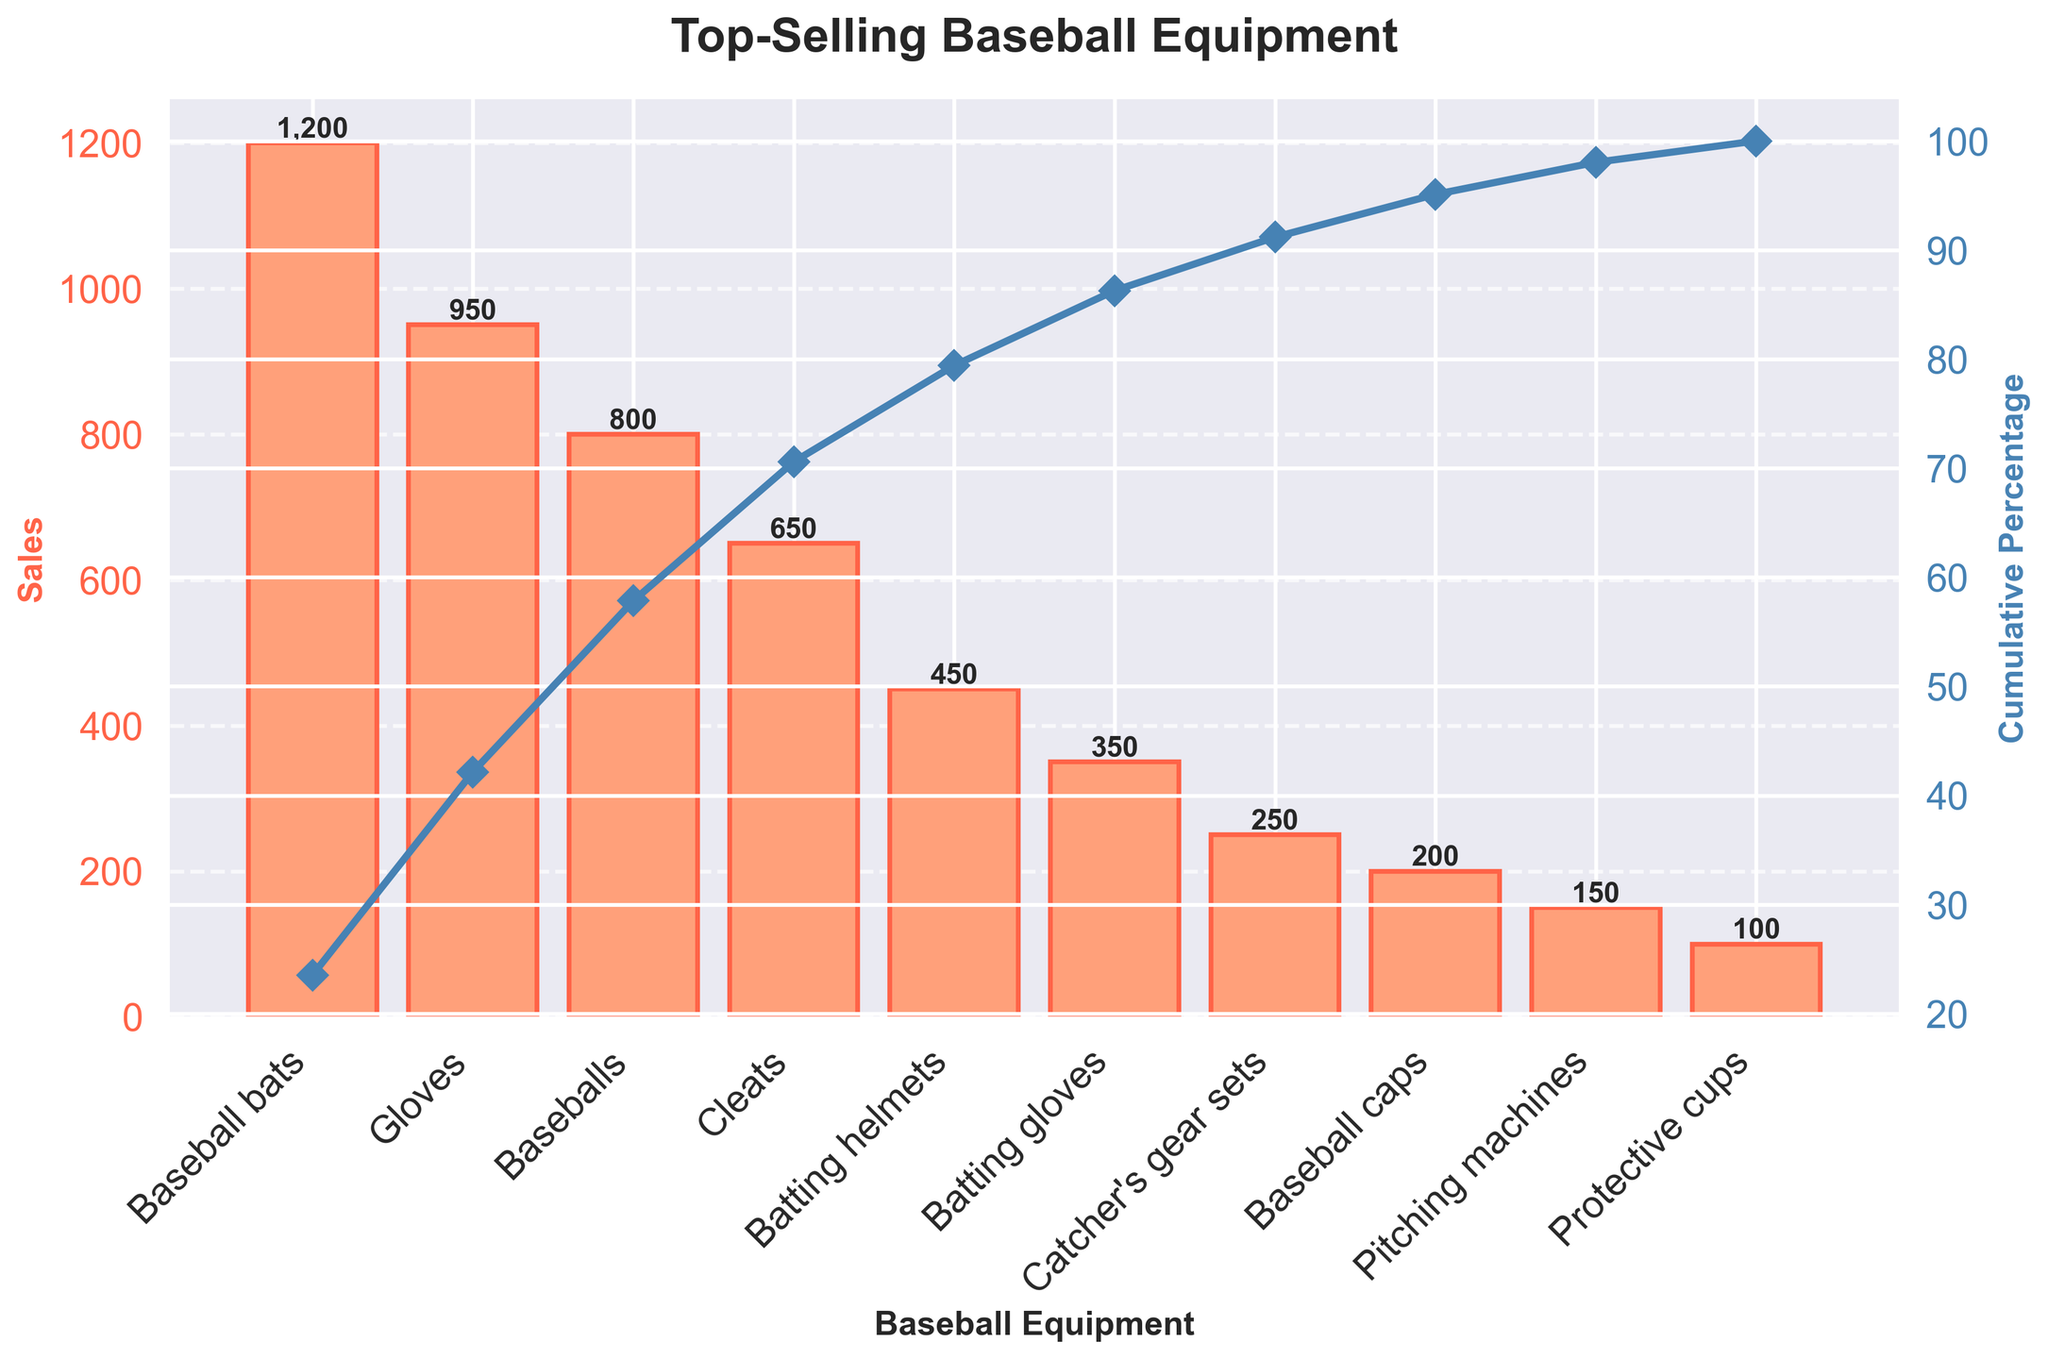What is the title of the chart? The title of a chart is typically located at the top and provides a summary of what the chart is about. In this case, it reads "Top-Selling Baseball Equipment".
Answer: Top-Selling Baseball Equipment Which item had the highest sales? The item with the highest sales will have the tallest bar on the bar chart. In this chart, the tallest bar represents the sales for Baseball bats.
Answer: Baseball bats What is the cumulative percentage for Batting helmets? Locate the Batting helmets bar on the x-axis. Follow the line corresponding to its height across to the right y-axis to find the cumulative percentage plotted by the line graph. This value is approximately 78%.
Answer: 78% By how much do the sales of Baseball bats exceed the sales of Baseballs? Find the height of the bars for both Baseball bats and Baseballs. Baseball bats have sales of 1200 and Baseballs have sales of 800. Subtract the sales of Baseballs from Baseball bats. 1200 - 800 = 400
Answer: 400 How many different types of baseball equipment are displayed in this chart? Count the number of distinct items listed on the x-axis. There are ten items in total.
Answer: 10 What percentage of the total sales is made up by the combination of Baseball bats, Gloves, and Baseballs? Add the sales of Baseball bats (1200), Gloves (950), and Baseballs (800) to get the total. 1200 + 950 + 800 = 2950. Next, compute the total sales of all items combined and divide the combined sales by this total, then multiply by 100 to get the percentage. 2950 / 5100 * 100 ≈ 57.84%
Answer: 57.84% Between Batting gloves and Catcher's gear sets, which one contributes less to the cumulative percentage, and by what amount? Compare the bars for Batting gloves (350) and Catcher's gear sets (250) for their sales figures. Subtract the sales of Catcher's gear sets from Batting gloves to find the difference. 350 - 250 = 100
Answer: Catcher's gear sets, 100 What color are the bars representing the sales values? Identify the color of the bars visually in the chart. They are colored in a shade of light orange.
Answer: Light orange How many items need to be included to reach more than 85% of cumulative sales? Identify the cumulative percentage values on the right y-axis and count how many items it takes to exceed 85%. This value occurs after including Batting helmets, the fifth item.
Answer: 5 What is the combined sales figure for the three items with the lowest sales? Identify the three items with the smallest bars: Pitching machines (150), Protective cups (100), and Baseball caps (200). Add their sales figures: 150 + 100 + 200 = 450
Answer: 450 